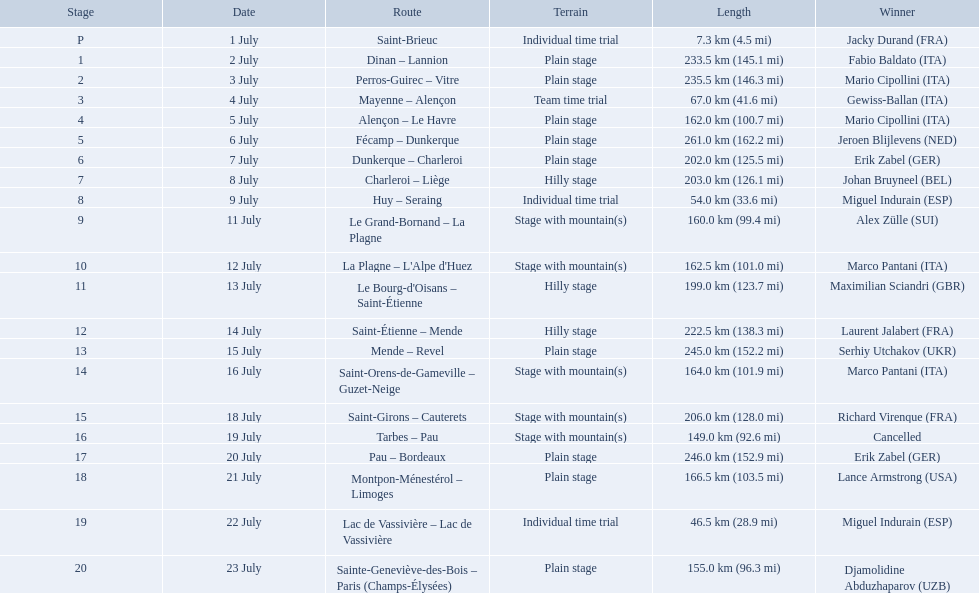What were the lengths of all the stages of the 1995 tour de france? 7.3 km (4.5 mi), 233.5 km (145.1 mi), 235.5 km (146.3 mi), 67.0 km (41.6 mi), 162.0 km (100.7 mi), 261.0 km (162.2 mi), 202.0 km (125.5 mi), 203.0 km (126.1 mi), 54.0 km (33.6 mi), 160.0 km (99.4 mi), 162.5 km (101.0 mi), 199.0 km (123.7 mi), 222.5 km (138.3 mi), 245.0 km (152.2 mi), 164.0 km (101.9 mi), 206.0 km (128.0 mi), 149.0 km (92.6 mi), 246.0 km (152.9 mi), 166.5 km (103.5 mi), 46.5 km (28.9 mi), 155.0 km (96.3 mi). Of those, which one occurred on july 8th? 203.0 km (126.1 mi). Parse the full table in json format. {'header': ['Stage', 'Date', 'Route', 'Terrain', 'Length', 'Winner'], 'rows': [['P', '1 July', 'Saint-Brieuc', 'Individual time trial', '7.3\xa0km (4.5\xa0mi)', 'Jacky Durand\xa0(FRA)'], ['1', '2 July', 'Dinan – Lannion', 'Plain stage', '233.5\xa0km (145.1\xa0mi)', 'Fabio Baldato\xa0(ITA)'], ['2', '3 July', 'Perros-Guirec – Vitre', 'Plain stage', '235.5\xa0km (146.3\xa0mi)', 'Mario Cipollini\xa0(ITA)'], ['3', '4 July', 'Mayenne – Alençon', 'Team time trial', '67.0\xa0km (41.6\xa0mi)', 'Gewiss-Ballan\xa0(ITA)'], ['4', '5 July', 'Alençon – Le Havre', 'Plain stage', '162.0\xa0km (100.7\xa0mi)', 'Mario Cipollini\xa0(ITA)'], ['5', '6 July', 'Fécamp – Dunkerque', 'Plain stage', '261.0\xa0km (162.2\xa0mi)', 'Jeroen Blijlevens\xa0(NED)'], ['6', '7 July', 'Dunkerque – Charleroi', 'Plain stage', '202.0\xa0km (125.5\xa0mi)', 'Erik Zabel\xa0(GER)'], ['7', '8 July', 'Charleroi – Liège', 'Hilly stage', '203.0\xa0km (126.1\xa0mi)', 'Johan Bruyneel\xa0(BEL)'], ['8', '9 July', 'Huy – Seraing', 'Individual time trial', '54.0\xa0km (33.6\xa0mi)', 'Miguel Indurain\xa0(ESP)'], ['9', '11 July', 'Le Grand-Bornand – La Plagne', 'Stage with mountain(s)', '160.0\xa0km (99.4\xa0mi)', 'Alex Zülle\xa0(SUI)'], ['10', '12 July', "La Plagne – L'Alpe d'Huez", 'Stage with mountain(s)', '162.5\xa0km (101.0\xa0mi)', 'Marco Pantani\xa0(ITA)'], ['11', '13 July', "Le Bourg-d'Oisans – Saint-Étienne", 'Hilly stage', '199.0\xa0km (123.7\xa0mi)', 'Maximilian Sciandri\xa0(GBR)'], ['12', '14 July', 'Saint-Étienne – Mende', 'Hilly stage', '222.5\xa0km (138.3\xa0mi)', 'Laurent Jalabert\xa0(FRA)'], ['13', '15 July', 'Mende – Revel', 'Plain stage', '245.0\xa0km (152.2\xa0mi)', 'Serhiy Utchakov\xa0(UKR)'], ['14', '16 July', 'Saint-Orens-de-Gameville – Guzet-Neige', 'Stage with mountain(s)', '164.0\xa0km (101.9\xa0mi)', 'Marco Pantani\xa0(ITA)'], ['15', '18 July', 'Saint-Girons – Cauterets', 'Stage with mountain(s)', '206.0\xa0km (128.0\xa0mi)', 'Richard Virenque\xa0(FRA)'], ['16', '19 July', 'Tarbes – Pau', 'Stage with mountain(s)', '149.0\xa0km (92.6\xa0mi)', 'Cancelled'], ['17', '20 July', 'Pau – Bordeaux', 'Plain stage', '246.0\xa0km (152.9\xa0mi)', 'Erik Zabel\xa0(GER)'], ['18', '21 July', 'Montpon-Ménestérol – Limoges', 'Plain stage', '166.5\xa0km (103.5\xa0mi)', 'Lance Armstrong\xa0(USA)'], ['19', '22 July', 'Lac de Vassivière – Lac de Vassivière', 'Individual time trial', '46.5\xa0km (28.9\xa0mi)', 'Miguel Indurain\xa0(ESP)'], ['20', '23 July', 'Sainte-Geneviève-des-Bois – Paris (Champs-Élysées)', 'Plain stage', '155.0\xa0km (96.3\xa0mi)', 'Djamolidine Abduzhaparov\xa0(UZB)']]} What were the distances of all the phases of the 1995 tour de france? 7.3 km (4.5 mi), 233.5 km (145.1 mi), 235.5 km (146.3 mi), 67.0 km (41.6 mi), 162.0 km (100.7 mi), 261.0 km (162.2 mi), 202.0 km (125.5 mi), 203.0 km (126.1 mi), 54.0 km (33.6 mi), 160.0 km (99.4 mi), 162.5 km (101.0 mi), 199.0 km (123.7 mi), 222.5 km (138.3 mi), 245.0 km (152.2 mi), 164.0 km (101.9 mi), 206.0 km (128.0 mi), 149.0 km (92.6 mi), 246.0 km (152.9 mi), 166.5 km (103.5 mi), 46.5 km (28.9 mi), 155.0 km (96.3 mi). Of these, which one took place on july 8th? 203.0 km (126.1 mi). What are the exact dates? 1 July, 2 July, 3 July, 4 July, 5 July, 6 July, 7 July, 8 July, 9 July, 11 July, 12 July, 13 July, 14 July, 15 July, 16 July, 18 July, 19 July, 20 July, 21 July, 22 July, 23 July. On july 8th, what is the length? 203.0 km (126.1 mi). 